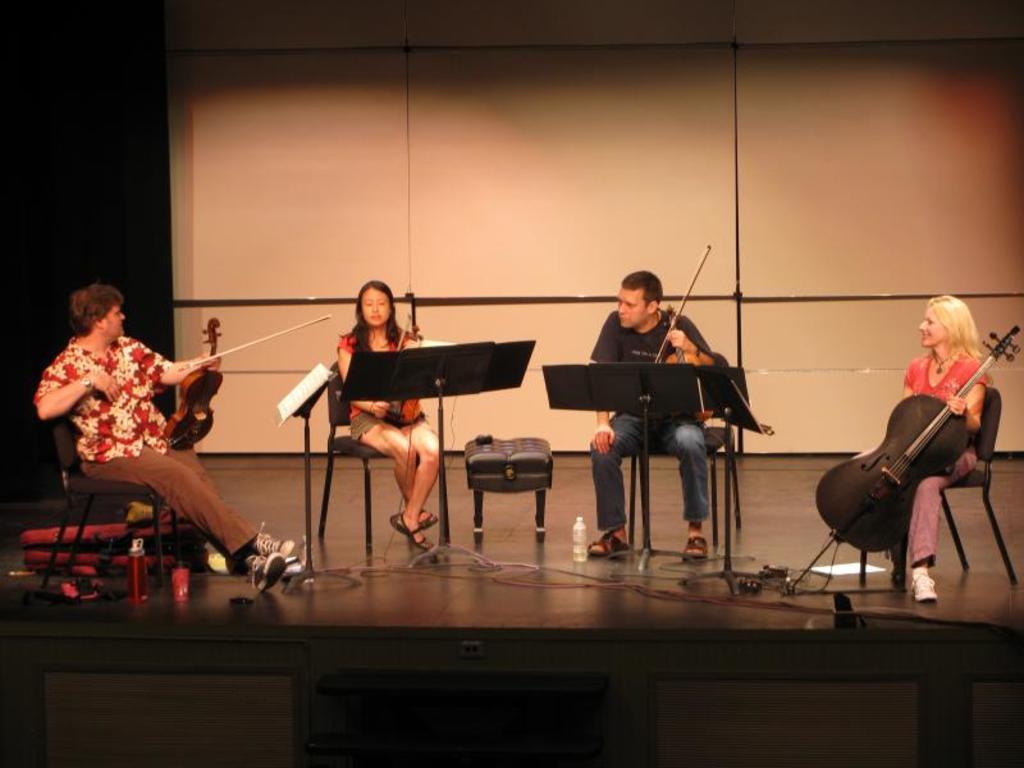Describe this image in one or two sentences. On this stage this four persons are sitting on chairs and holding musical instruments. On floor there are cables, bottle, paper and bag. This is book stand. 